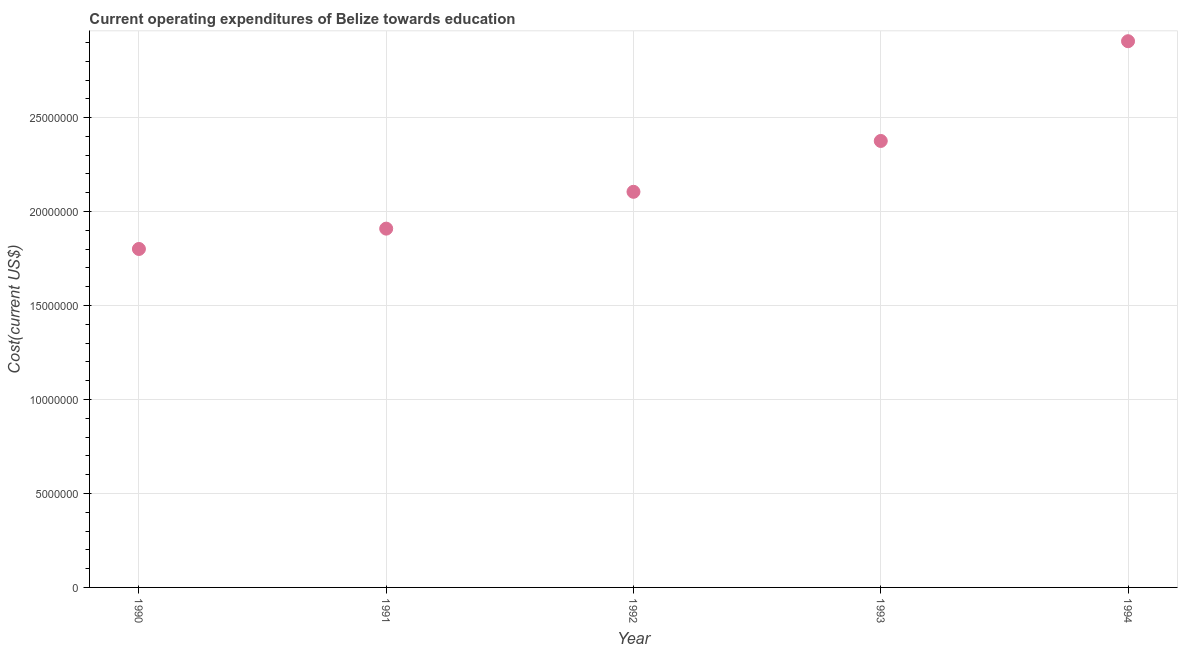What is the education expenditure in 1992?
Keep it short and to the point. 2.11e+07. Across all years, what is the maximum education expenditure?
Provide a succinct answer. 2.91e+07. Across all years, what is the minimum education expenditure?
Offer a very short reply. 1.80e+07. In which year was the education expenditure maximum?
Provide a short and direct response. 1994. In which year was the education expenditure minimum?
Offer a very short reply. 1990. What is the sum of the education expenditure?
Provide a short and direct response. 1.11e+08. What is the difference between the education expenditure in 1992 and 1994?
Your answer should be very brief. -8.01e+06. What is the average education expenditure per year?
Offer a very short reply. 2.22e+07. What is the median education expenditure?
Give a very brief answer. 2.11e+07. Do a majority of the years between 1991 and 1990 (inclusive) have education expenditure greater than 12000000 US$?
Your answer should be compact. No. What is the ratio of the education expenditure in 1993 to that in 1994?
Your response must be concise. 0.82. Is the education expenditure in 1992 less than that in 1993?
Your response must be concise. Yes. Is the difference between the education expenditure in 1990 and 1992 greater than the difference between any two years?
Provide a short and direct response. No. What is the difference between the highest and the second highest education expenditure?
Your answer should be very brief. 5.31e+06. What is the difference between the highest and the lowest education expenditure?
Offer a very short reply. 1.11e+07. In how many years, is the education expenditure greater than the average education expenditure taken over all years?
Your response must be concise. 2. Does the education expenditure monotonically increase over the years?
Offer a very short reply. Yes. How many dotlines are there?
Ensure brevity in your answer.  1. What is the difference between two consecutive major ticks on the Y-axis?
Ensure brevity in your answer.  5.00e+06. Does the graph contain any zero values?
Provide a succinct answer. No. What is the title of the graph?
Keep it short and to the point. Current operating expenditures of Belize towards education. What is the label or title of the X-axis?
Give a very brief answer. Year. What is the label or title of the Y-axis?
Your answer should be compact. Cost(current US$). What is the Cost(current US$) in 1990?
Offer a very short reply. 1.80e+07. What is the Cost(current US$) in 1991?
Make the answer very short. 1.91e+07. What is the Cost(current US$) in 1992?
Offer a very short reply. 2.11e+07. What is the Cost(current US$) in 1993?
Provide a succinct answer. 2.38e+07. What is the Cost(current US$) in 1994?
Provide a succinct answer. 2.91e+07. What is the difference between the Cost(current US$) in 1990 and 1991?
Make the answer very short. -1.08e+06. What is the difference between the Cost(current US$) in 1990 and 1992?
Ensure brevity in your answer.  -3.04e+06. What is the difference between the Cost(current US$) in 1990 and 1993?
Keep it short and to the point. -5.75e+06. What is the difference between the Cost(current US$) in 1990 and 1994?
Provide a succinct answer. -1.11e+07. What is the difference between the Cost(current US$) in 1991 and 1992?
Give a very brief answer. -1.96e+06. What is the difference between the Cost(current US$) in 1991 and 1993?
Your answer should be very brief. -4.67e+06. What is the difference between the Cost(current US$) in 1991 and 1994?
Your answer should be very brief. -9.97e+06. What is the difference between the Cost(current US$) in 1992 and 1993?
Your answer should be very brief. -2.71e+06. What is the difference between the Cost(current US$) in 1992 and 1994?
Your answer should be compact. -8.01e+06. What is the difference between the Cost(current US$) in 1993 and 1994?
Your response must be concise. -5.31e+06. What is the ratio of the Cost(current US$) in 1990 to that in 1991?
Offer a terse response. 0.94. What is the ratio of the Cost(current US$) in 1990 to that in 1992?
Keep it short and to the point. 0.86. What is the ratio of the Cost(current US$) in 1990 to that in 1993?
Your answer should be very brief. 0.76. What is the ratio of the Cost(current US$) in 1990 to that in 1994?
Keep it short and to the point. 0.62. What is the ratio of the Cost(current US$) in 1991 to that in 1992?
Your response must be concise. 0.91. What is the ratio of the Cost(current US$) in 1991 to that in 1993?
Provide a succinct answer. 0.8. What is the ratio of the Cost(current US$) in 1991 to that in 1994?
Provide a short and direct response. 0.66. What is the ratio of the Cost(current US$) in 1992 to that in 1993?
Offer a terse response. 0.89. What is the ratio of the Cost(current US$) in 1992 to that in 1994?
Make the answer very short. 0.72. What is the ratio of the Cost(current US$) in 1993 to that in 1994?
Your response must be concise. 0.82. 